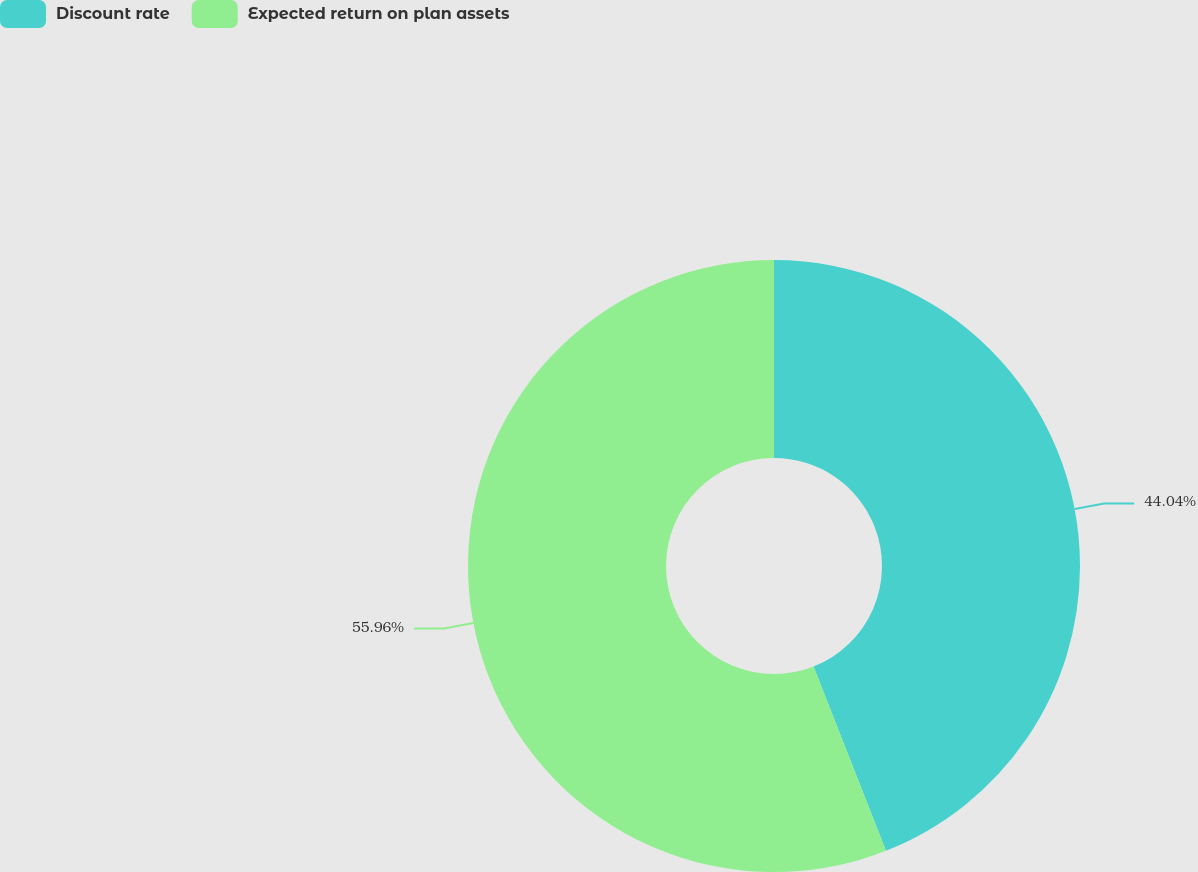Convert chart. <chart><loc_0><loc_0><loc_500><loc_500><pie_chart><fcel>Discount rate<fcel>Expected return on plan assets<nl><fcel>44.04%<fcel>55.96%<nl></chart> 